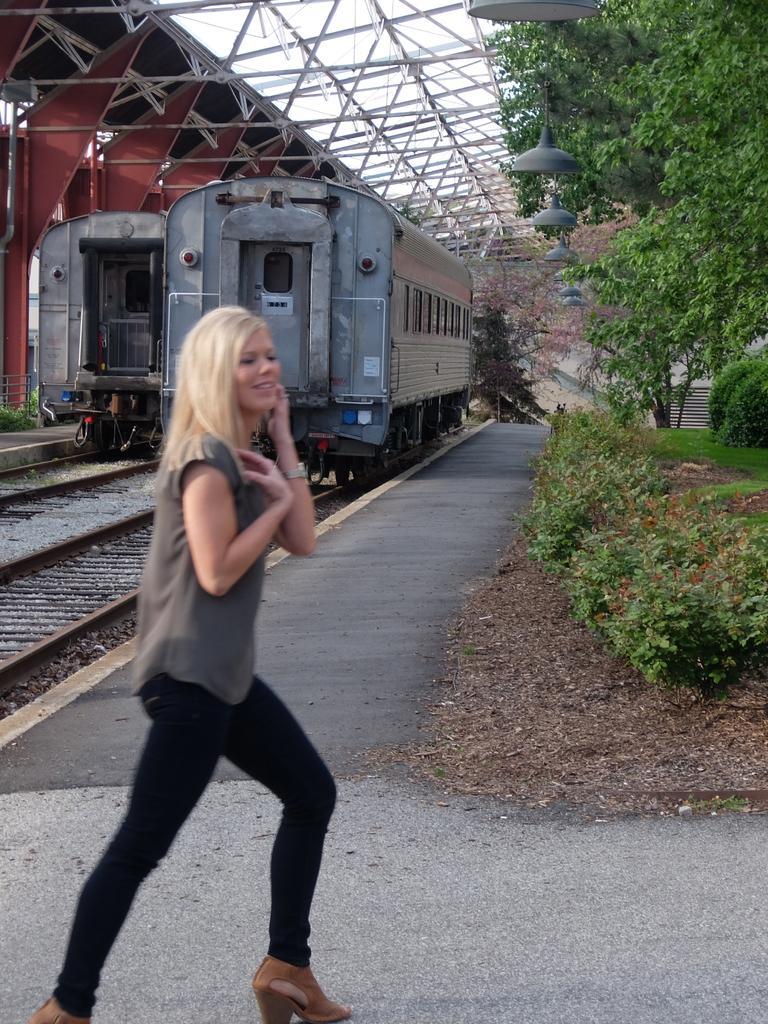In one or two sentences, can you explain what this image depicts? In this picture there is a woman standing and there are two trains on two tracks behind her and there are few iron rods above the train and there are few plants,trees and lights in the right corner. 